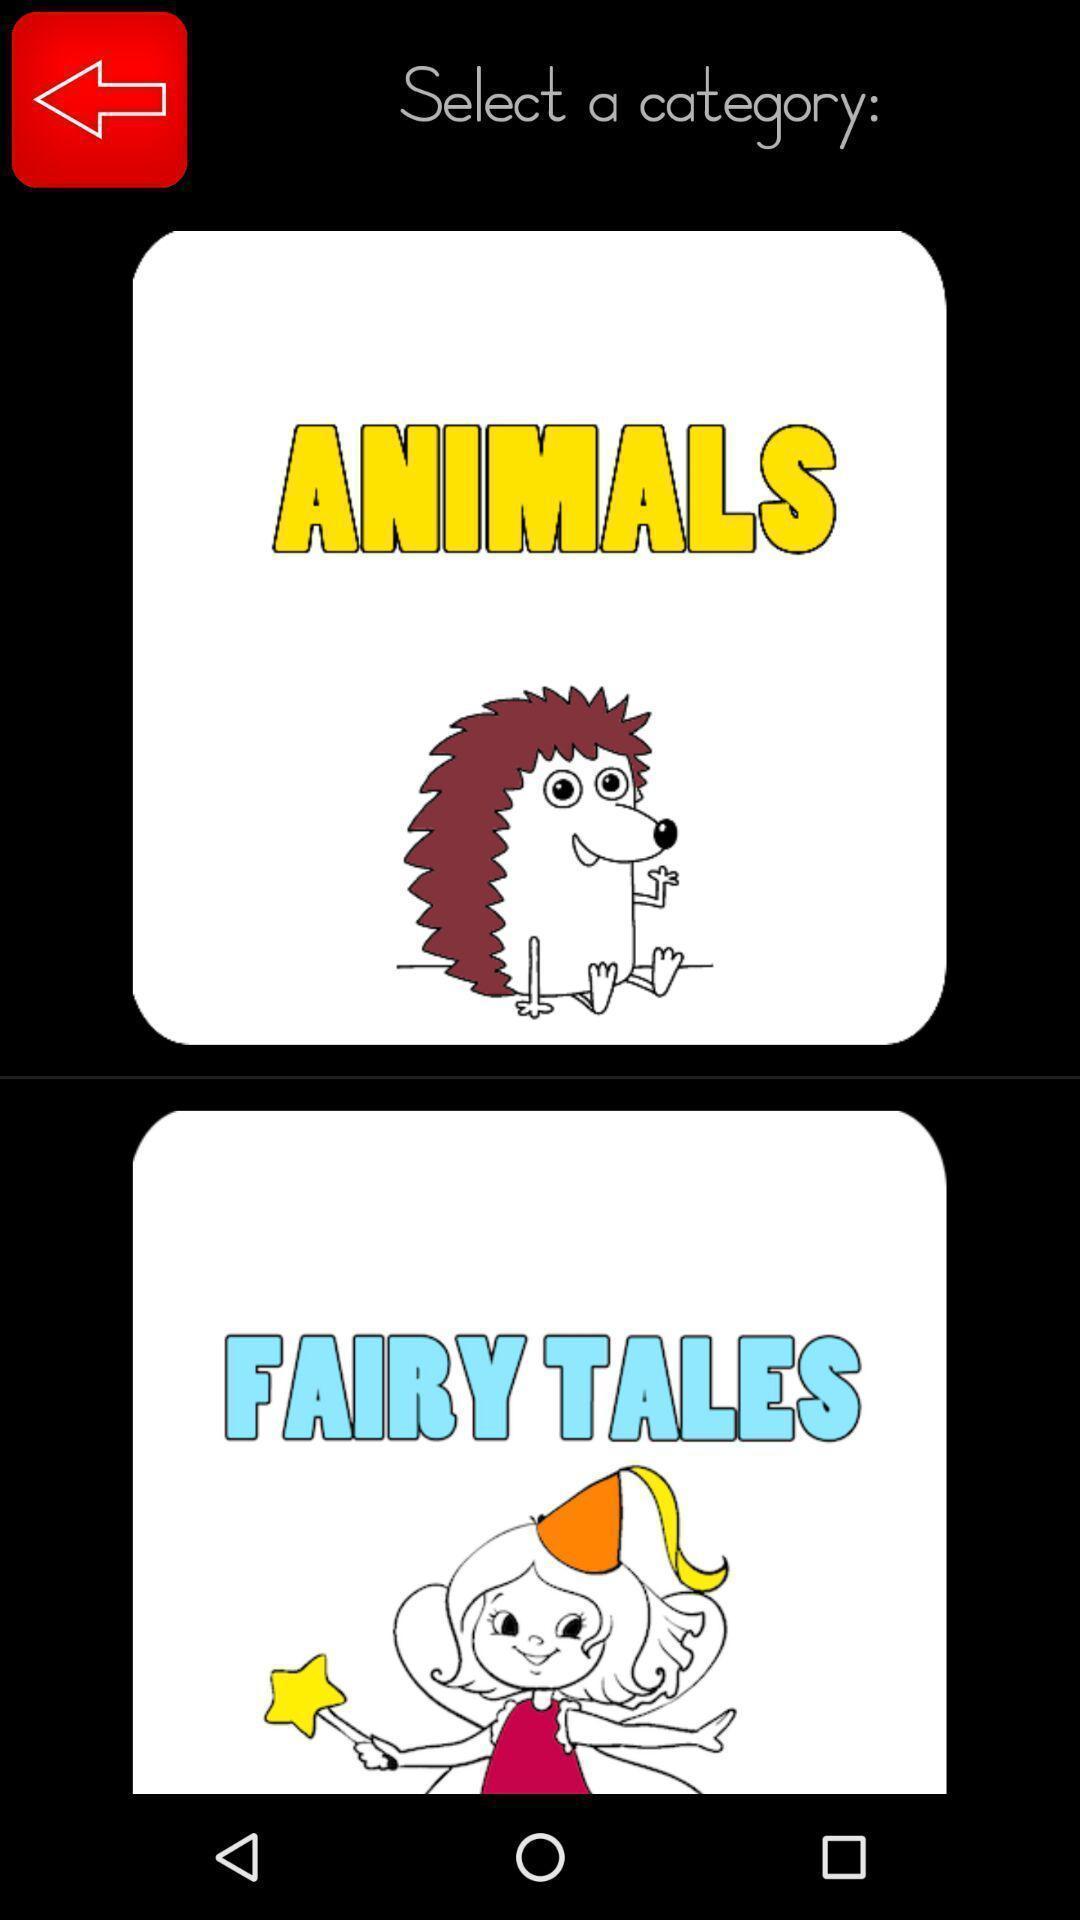Describe this image in words. Screen showing categories. 